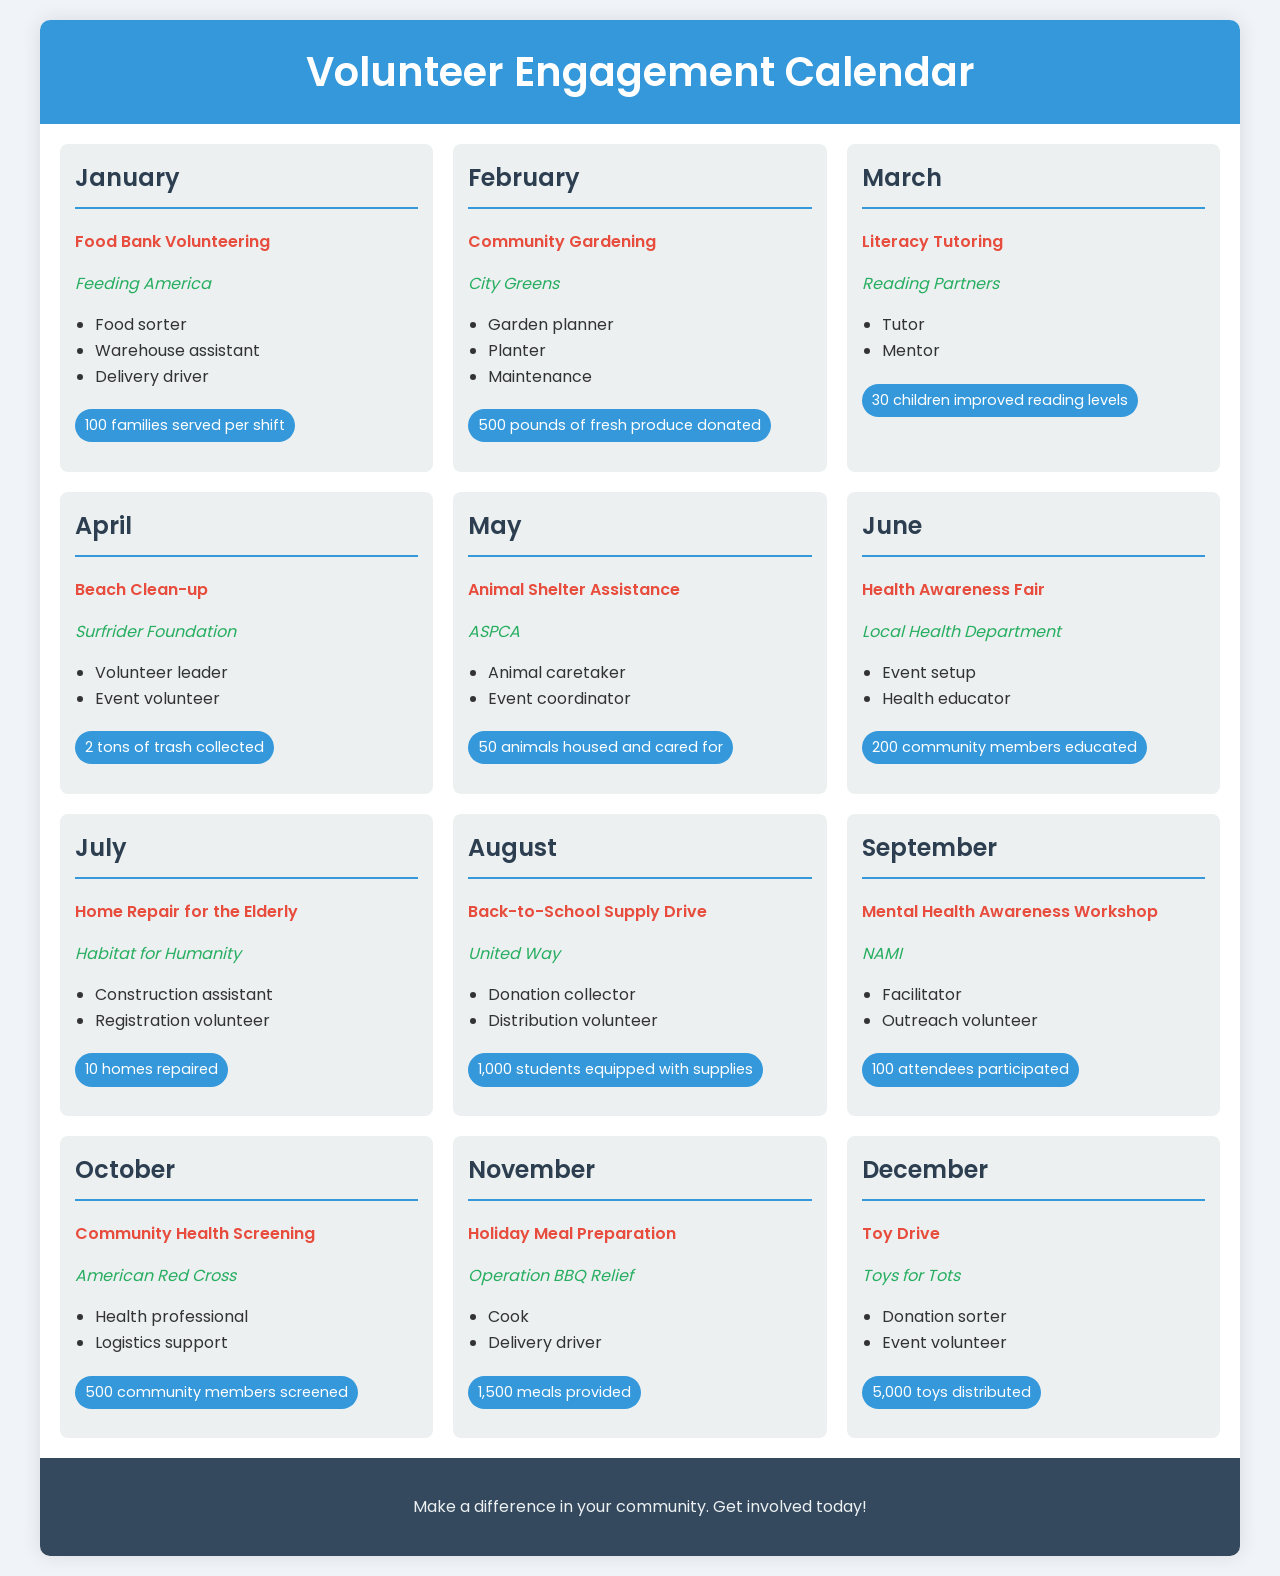What is the opportunity in January? The opportunity listed for January is Food Bank Volunteering.
Answer: Food Bank Volunteering Who is the organization for the Beach Clean-up in April? The organization associated with the Beach Clean-up is the Surfrider Foundation.
Answer: Surfrider Foundation How many animals are housed and cared for in May? The document states that 50 animals are housed and cared for in May.
Answer: 50 animals What are the roles available for the Mental Health Awareness Workshop in September? The roles available include Facilitator and Outreach volunteer.
Answer: Facilitator, Outreach volunteer What is the impact measure for the Toy Drive in December? The impact measure for the Toy Drive indicates that 5,000 toys are distributed.
Answer: 5,000 toys How many community members are educated during the Health Awareness Fair in June? The document mentions that 200 community members are educated during this event.
Answer: 200 community members What is the common theme represented across opportunities in this calendar? The calendar highlights community involvement and support through various social causes.
Answer: Community involvement In which month is the Back-to-School Supply Drive taking place? The document specifies that the Back-to-School Supply Drive is in August.
Answer: August Which opportunity involves animal care? The opportunity involving animal care is Animal Shelter Assistance.
Answer: Animal Shelter Assistance 